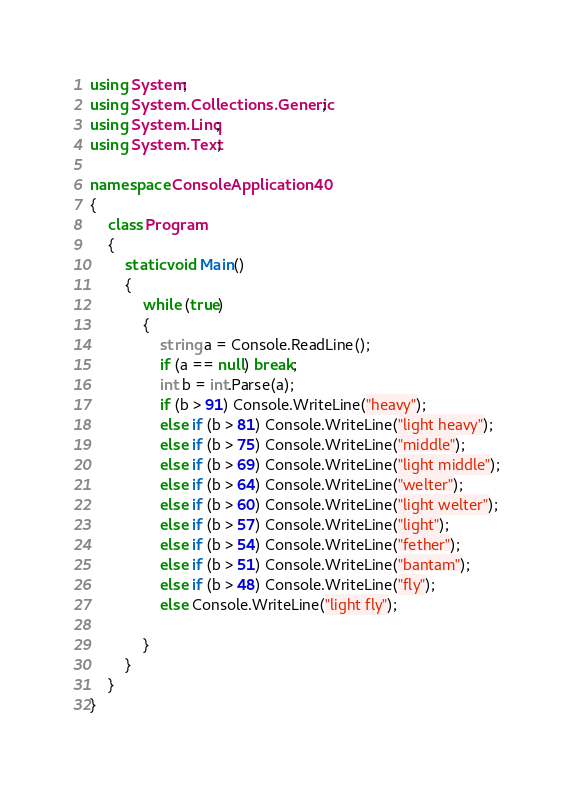Convert code to text. <code><loc_0><loc_0><loc_500><loc_500><_C#_>using System;
using System.Collections.Generic;
using System.Linq;
using System.Text;

namespace ConsoleApplication40
{
    class Program
    {
        static void Main()
        {
            while (true)
            {
                string a = Console.ReadLine();
                if (a == null) break;
                int b = int.Parse(a);
                if (b > 91) Console.WriteLine("heavy");
                else if (b > 81) Console.WriteLine("light heavy");
                else if (b > 75) Console.WriteLine("middle");
                else if (b > 69) Console.WriteLine("light middle");
                else if (b > 64) Console.WriteLine("welter");
                else if (b > 60) Console.WriteLine("light welter");
                else if (b > 57) Console.WriteLine("light");
                else if (b > 54) Console.WriteLine("fether");
                else if (b > 51) Console.WriteLine("bantam");
                else if (b > 48) Console.WriteLine("fly");
                else Console.WriteLine("light fly");

            }
        }
    }
}</code> 